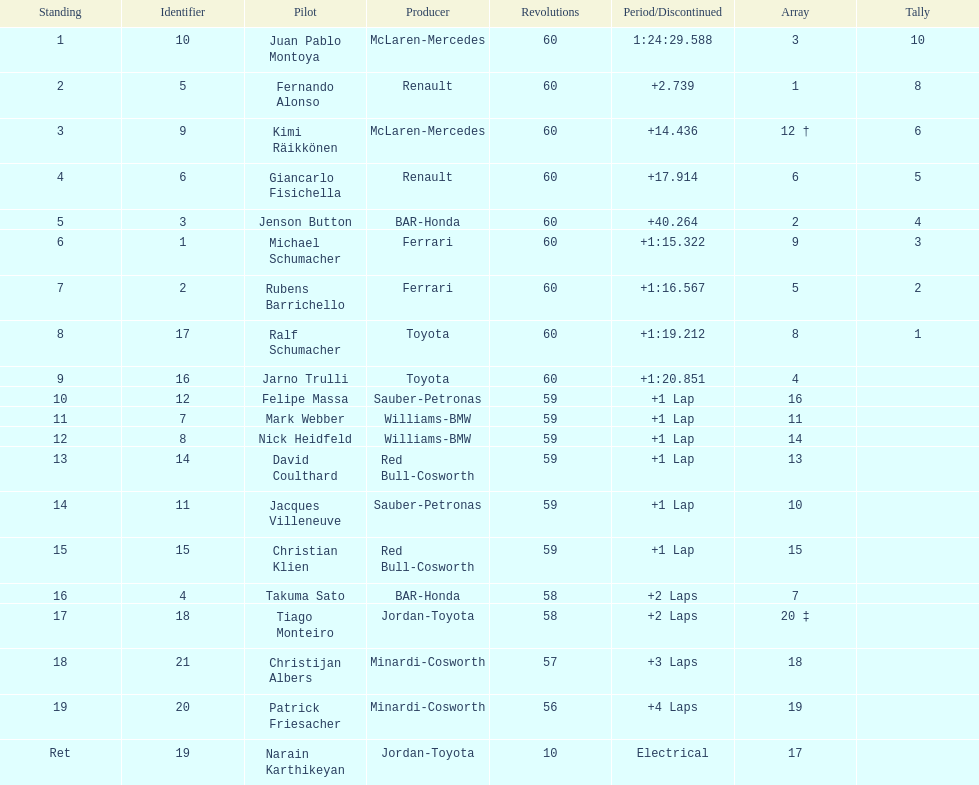Which driver has the least amount of points? Ralf Schumacher. 